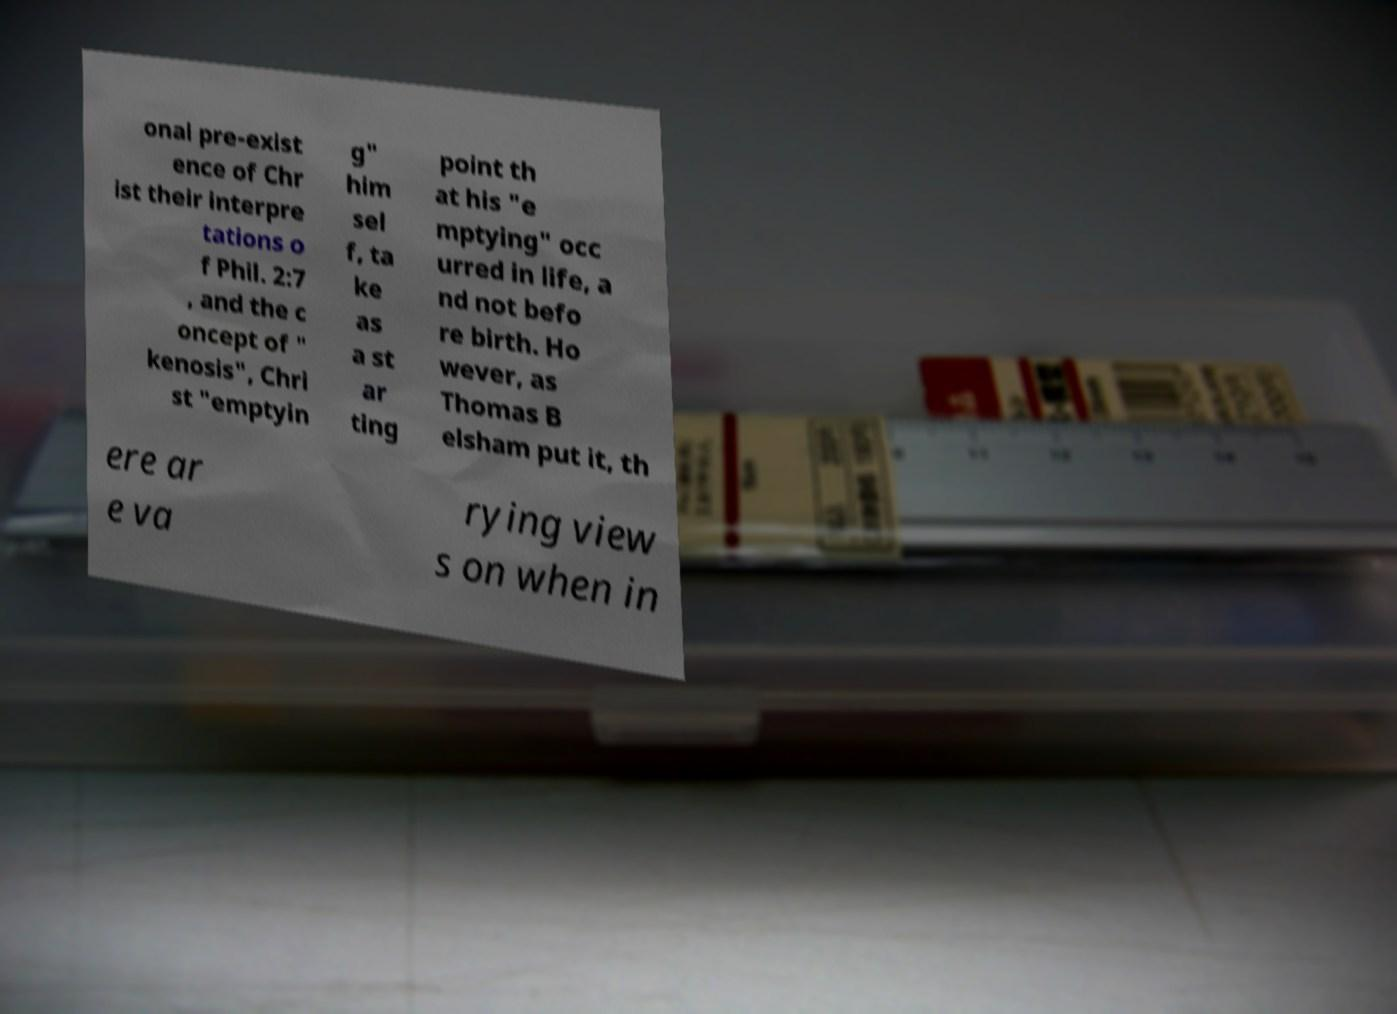Could you extract and type out the text from this image? onal pre-exist ence of Chr ist their interpre tations o f Phil. 2:7 , and the c oncept of " kenosis", Chri st "emptyin g" him sel f, ta ke as a st ar ting point th at his "e mptying" occ urred in life, a nd not befo re birth. Ho wever, as Thomas B elsham put it, th ere ar e va rying view s on when in 